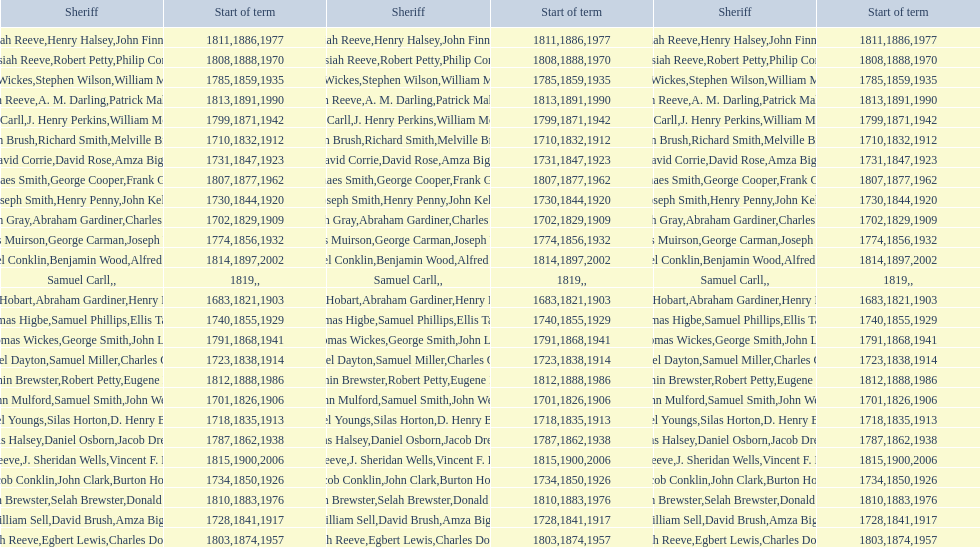Who was the sheriff preceding thomas wickes? James Muirson. Can you give me this table as a dict? {'header': ['Sheriff', 'Start of term', 'Sheriff', 'Start of term', 'Sheriff', 'Start of term'], 'rows': [['Josiah Reeve', '1811', 'Henry Halsey', '1886', 'John Finnerty', '1977'], ['Josiah Reeve', '1808', 'Robert Petty', '1888', 'Philip Corso', '1970'], ['Thomas Wickes', '1785', 'Stephen Wilson', '1859', 'William McCollom', '1935'], ['Josiah Reeve', '1813', 'A. M. Darling', '1891', 'Patrick Mahoney', '1990'], ['Phinaes Carll', '1799', 'J. Henry Perkins', '1871', 'William McCollom', '1942'], ['John Brush', '1710', 'Richard Smith', '1832', 'Melville Brush', '1912'], ['David Corrie', '1731', 'David Rose', '1847', 'Amza Biggs', '1923'], ['Phinaes Smith', '1807', 'George Cooper', '1877', 'Frank Gross', '1962'], ['Joseph Smith', '1730', 'Henry Penny', '1844', 'John Kelly', '1920'], ['Hugh Gray', '1702', 'Abraham Gardiner', '1829', 'Charles Platt', '1909'], ['James Muirson', '1774', 'George Carman', '1856', 'Joseph Warta', '1932'], ['Nathaniel Conklin', '1814', 'Benjamin Wood', '1897', 'Alfred C. Tisch', '2002'], ['Samuel Carll', '1819', '', '', '', ''], ['Josiah Hobart', '1683', 'Abraham Gardiner', '1821', 'Henry Preston', '1903'], ['Thomas Higbe', '1740', 'Samuel Phillips', '1855', 'Ellis Taylor', '1929'], ['Thomas Wickes', '1791', 'George Smith', '1868', 'John Levy', '1941'], ['Samuel Dayton', '1723', 'Samuel Miller', '1838', "Charles O'Dell", '1914'], ['Benjamin Brewster', '1812', 'Robert Petty', '1888', 'Eugene Dooley', '1986'], ['John Mulford', '1701', 'Samuel Smith', '1826', 'John Wells', '1906'], ['Daniel Youngs', '1718', 'Silas Horton', '1835', 'D. Henry Brown', '1913'], ['Silas Halsey', '1787', 'Daniel Osborn', '1862', 'Jacob Dreyer', '1938'], ['Josiah Reeve', '1815', 'J. Sheridan Wells', '1900', 'Vincent F. DeMarco', '2006'], ['Jacob Conklin', '1734', 'John Clark', '1850', 'Burton Howe', '1926'], ['Benjamin Brewster', '1810', 'Selah Brewster', '1883', 'Donald Dilworth', '1976'], ['William Sell', '1728', 'David Brush', '1841', 'Amza Biggs', '1917'], ['Josiah Reeve', '1803', 'Egbert Lewis', '1874', 'Charles Dominy', '1957']]} 